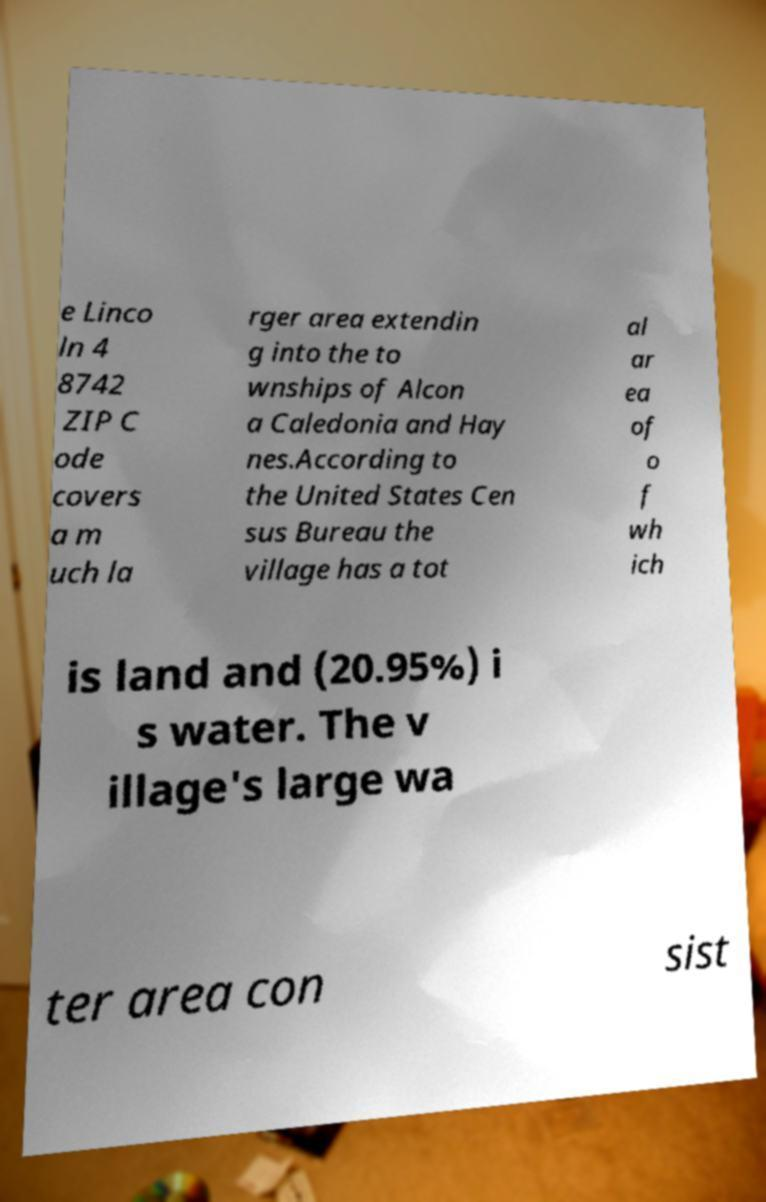Can you read and provide the text displayed in the image?This photo seems to have some interesting text. Can you extract and type it out for me? e Linco ln 4 8742 ZIP C ode covers a m uch la rger area extendin g into the to wnships of Alcon a Caledonia and Hay nes.According to the United States Cen sus Bureau the village has a tot al ar ea of o f wh ich is land and (20.95%) i s water. The v illage's large wa ter area con sist 